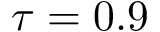<formula> <loc_0><loc_0><loc_500><loc_500>\tau = 0 . 9</formula> 